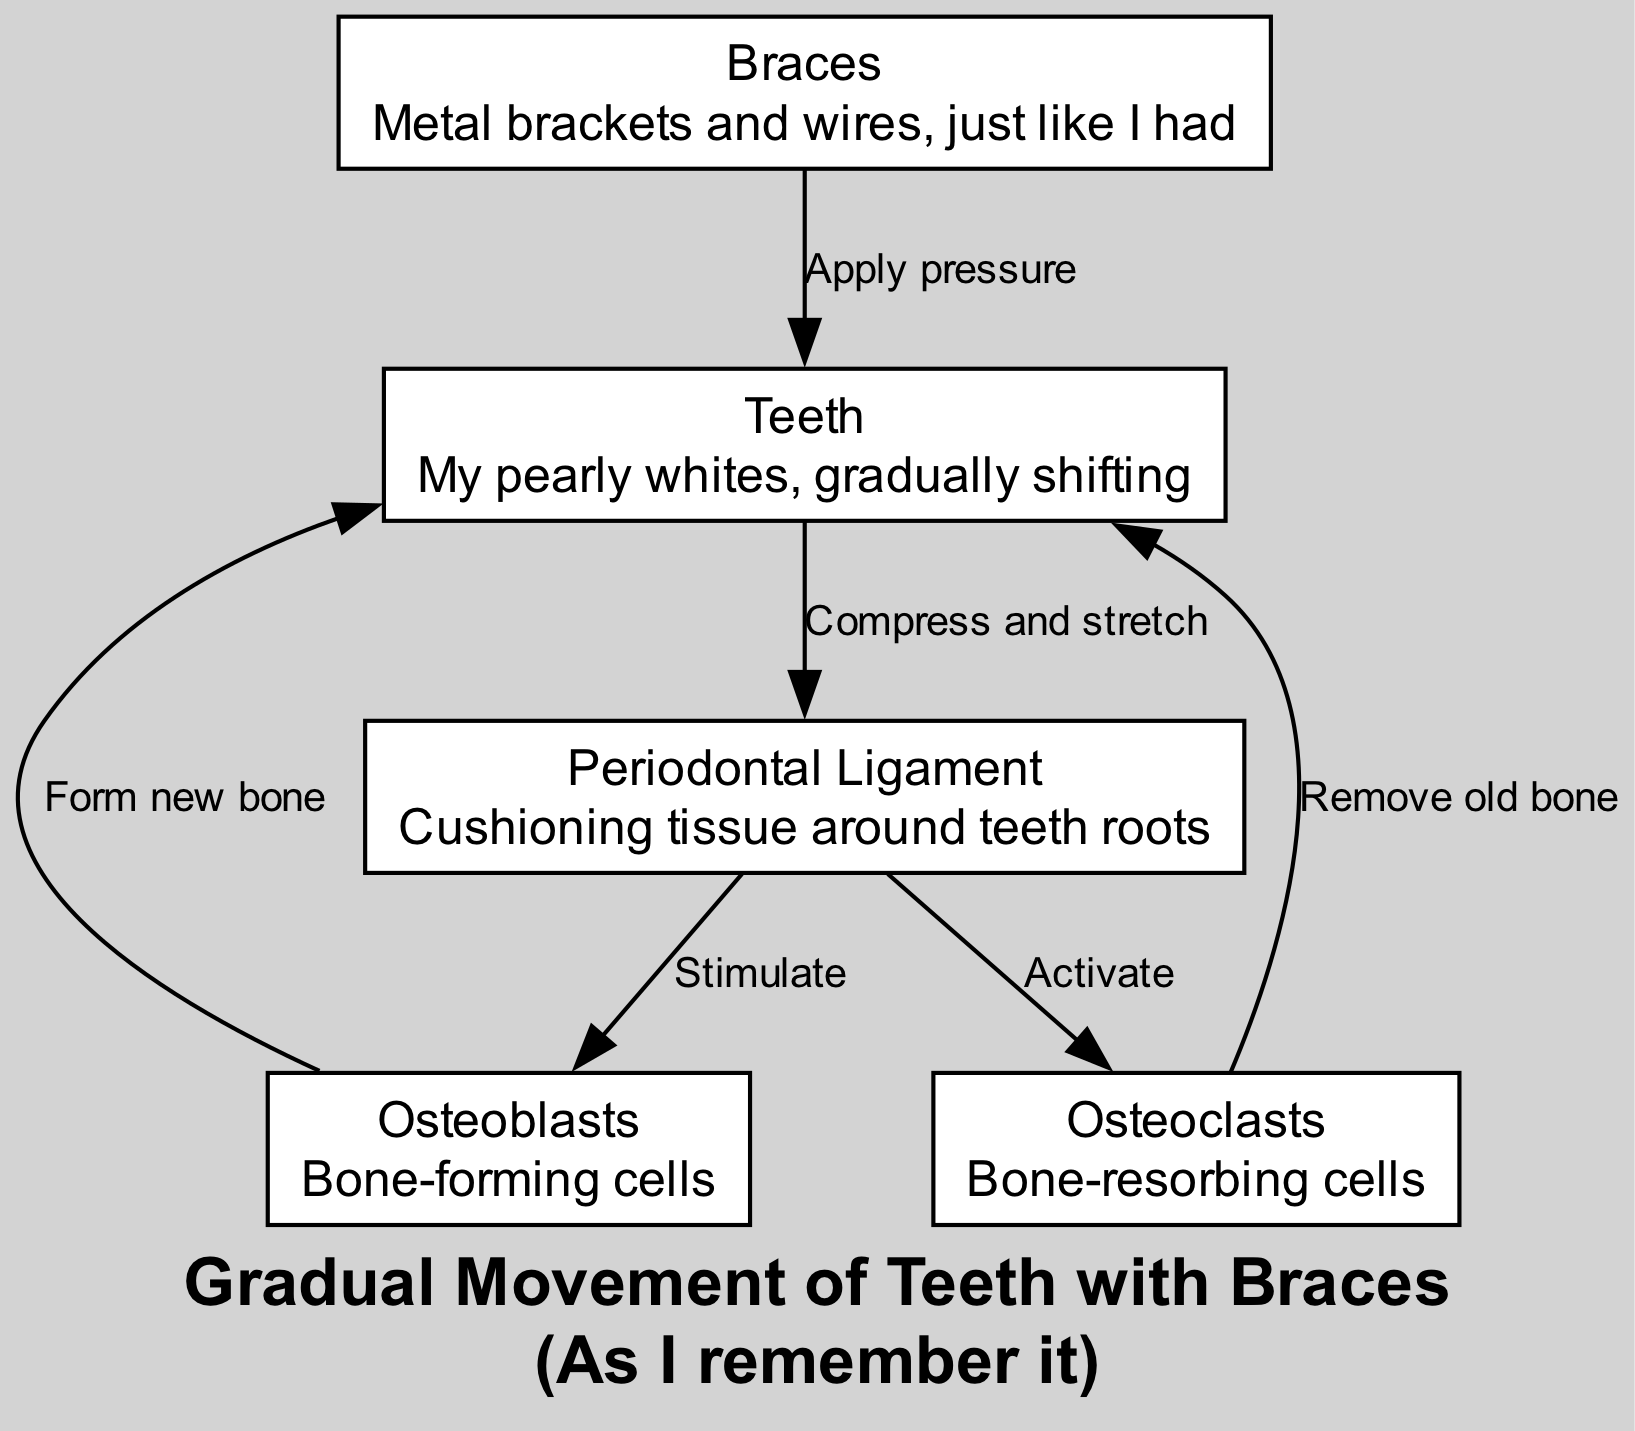What are the main components shown in the diagram? The diagram includes nodes for teeth, braces, periodontal ligament, osteoblasts, and osteoclasts. Each component plays a significant role in the process of teeth movement with braces.
Answer: teeth, braces, periodontal ligament, osteoblasts, osteoclasts How many edges are depicted in the diagram? The diagram shows six edges connecting the various components, illustrating the interactions and processes at play during the movement of teeth with braces.
Answer: six What does braces apply to in the diagram? The braces apply pressure directly to the teeth, which initiates the process of moving the teeth through the application of force.
Answer: teeth What do osteoblasts do in the process? Osteoblasts are stimulated by the periodontal ligament to form new bone, which is essential for supporting the newly positioned teeth.
Answer: Form new bone How does the periodontal ligament react when teeth are compressed? When the teeth are compressed, the periodontal ligament is stretched and compressed, allowing for the signaling of bone remodeling processes needed for teeth alignment.
Answer: Compress and stretch What role do osteoclasts play in the teeth movement process? Osteoclasts are activated by the periodontal ligament to remove old bone, which creates space for osteoblasts to form new bone and allows for the gradual movement of teeth.
Answer: Remove old bone How are the periodontal ligaments stimulated by braces? The braces apply pressure to the teeth, which in turn compresses and stretches the periodontal ligaments, leading to their stimulation and subsequently activating osteoblasts and osteoclasts for bone remodeling.
Answer: Apply pressure 